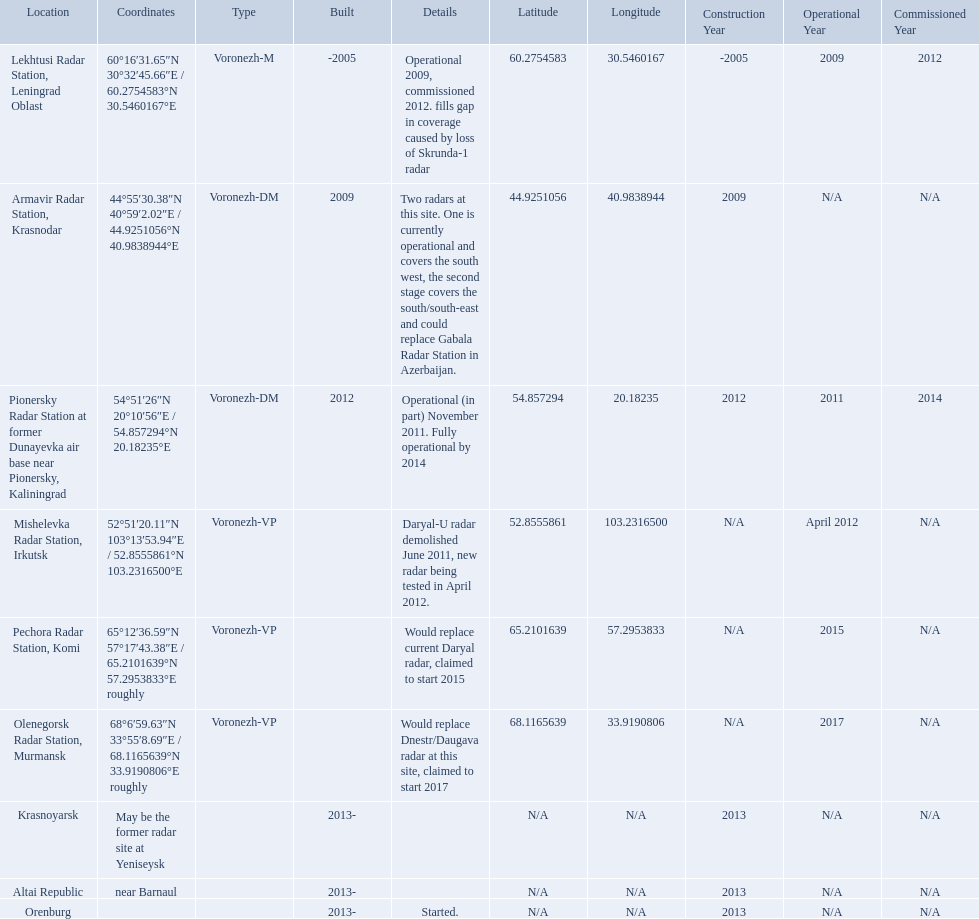Voronezh radar has locations where? Lekhtusi Radar Station, Leningrad Oblast, Armavir Radar Station, Krasnodar, Pionersky Radar Station at former Dunayevka air base near Pionersky, Kaliningrad, Mishelevka Radar Station, Irkutsk, Pechora Radar Station, Komi, Olenegorsk Radar Station, Murmansk, Krasnoyarsk, Altai Republic, Orenburg. Which of these locations have know coordinates? Lekhtusi Radar Station, Leningrad Oblast, Armavir Radar Station, Krasnodar, Pionersky Radar Station at former Dunayevka air base near Pionersky, Kaliningrad, Mishelevka Radar Station, Irkutsk, Pechora Radar Station, Komi, Olenegorsk Radar Station, Murmansk. Which of these locations has coordinates of 60deg16'31.65''n 30deg32'45.66''e / 60.2754583degn 30.5460167dege? Lekhtusi Radar Station, Leningrad Oblast. 